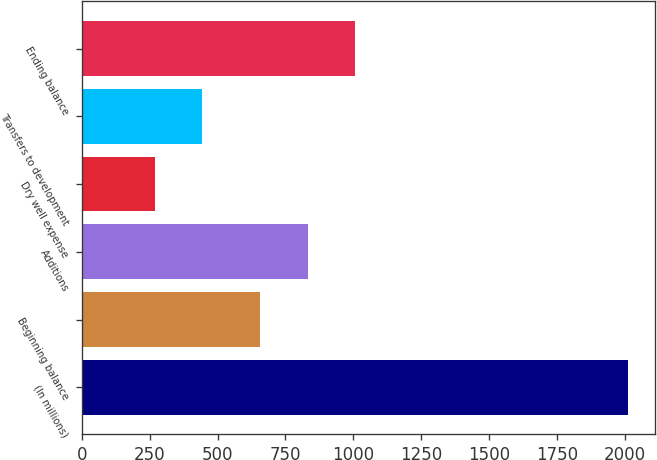<chart> <loc_0><loc_0><loc_500><loc_500><bar_chart><fcel>(In millions)<fcel>Beginning balance<fcel>Additions<fcel>Dry well expense<fcel>Transfers to development<fcel>Ending balance<nl><fcel>2011<fcel>657<fcel>831.3<fcel>268<fcel>442.3<fcel>1005.6<nl></chart> 